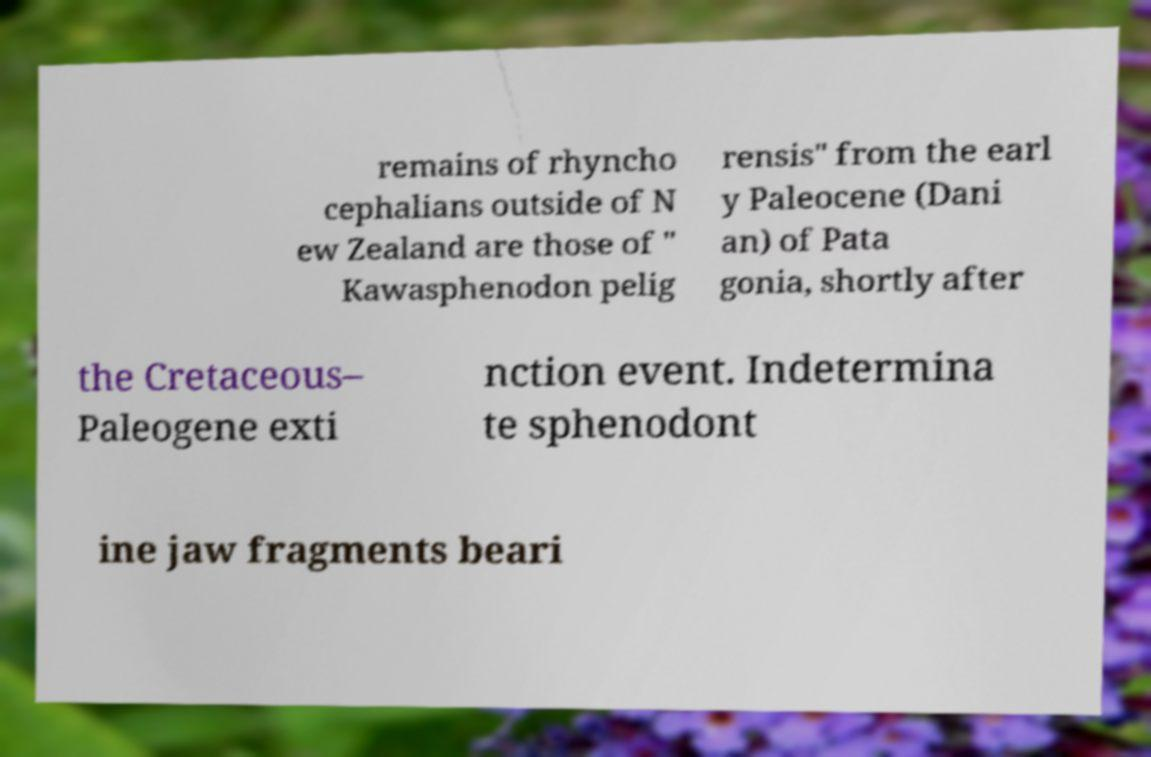I need the written content from this picture converted into text. Can you do that? remains of rhyncho cephalians outside of N ew Zealand are those of " Kawasphenodon pelig rensis" from the earl y Paleocene (Dani an) of Pata gonia, shortly after the Cretaceous– Paleogene exti nction event. Indetermina te sphenodont ine jaw fragments beari 